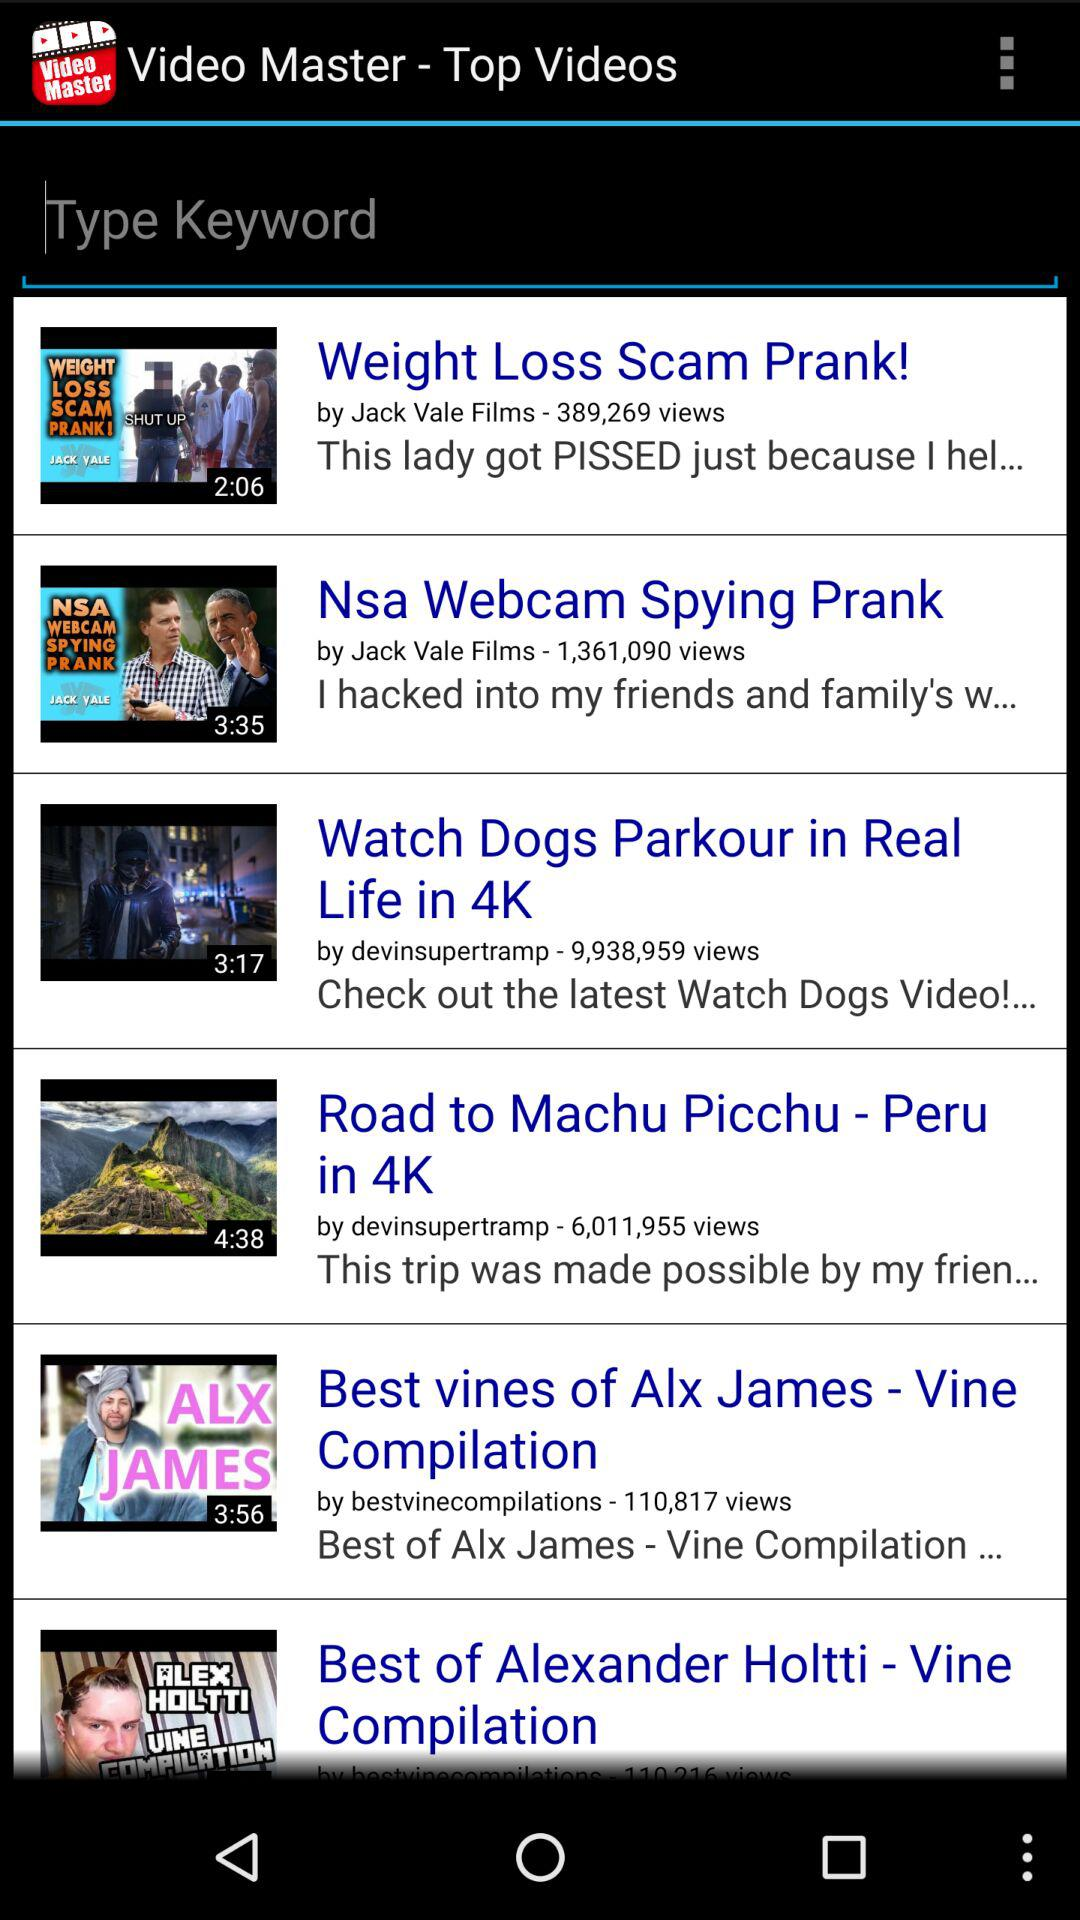What is the duration of "Weight Loss Scam Prank!"? The duration is 2 minutes and 6 seconds. 